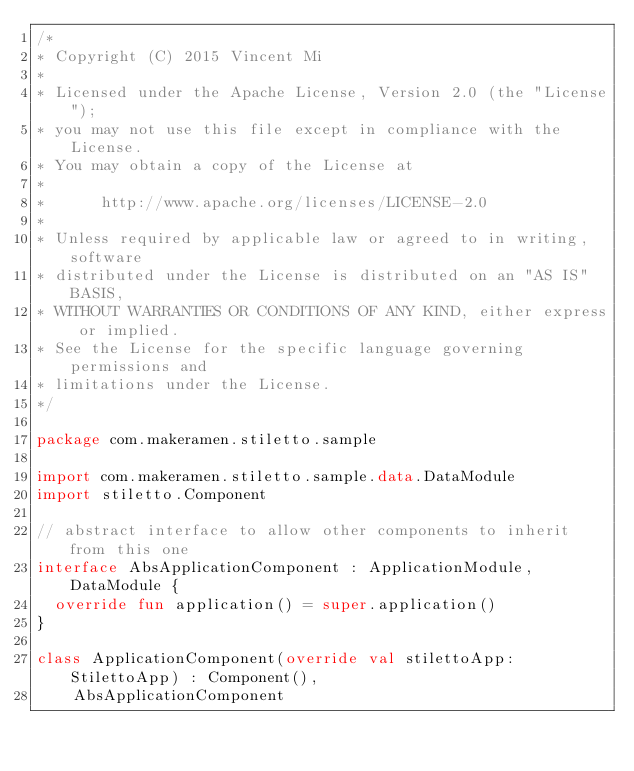<code> <loc_0><loc_0><loc_500><loc_500><_Kotlin_>/*
* Copyright (C) 2015 Vincent Mi
*
* Licensed under the Apache License, Version 2.0 (the "License");
* you may not use this file except in compliance with the License.
* You may obtain a copy of the License at
*
*      http://www.apache.org/licenses/LICENSE-2.0
*
* Unless required by applicable law or agreed to in writing, software
* distributed under the License is distributed on an "AS IS" BASIS,
* WITHOUT WARRANTIES OR CONDITIONS OF ANY KIND, either express or implied.
* See the License for the specific language governing permissions and
* limitations under the License.
*/

package com.makeramen.stiletto.sample

import com.makeramen.stiletto.sample.data.DataModule
import stiletto.Component

// abstract interface to allow other components to inherit from this one
interface AbsApplicationComponent : ApplicationModule, DataModule {
  override fun application() = super.application()
}

class ApplicationComponent(override val stilettoApp: StilettoApp) : Component(),
    AbsApplicationComponent</code> 